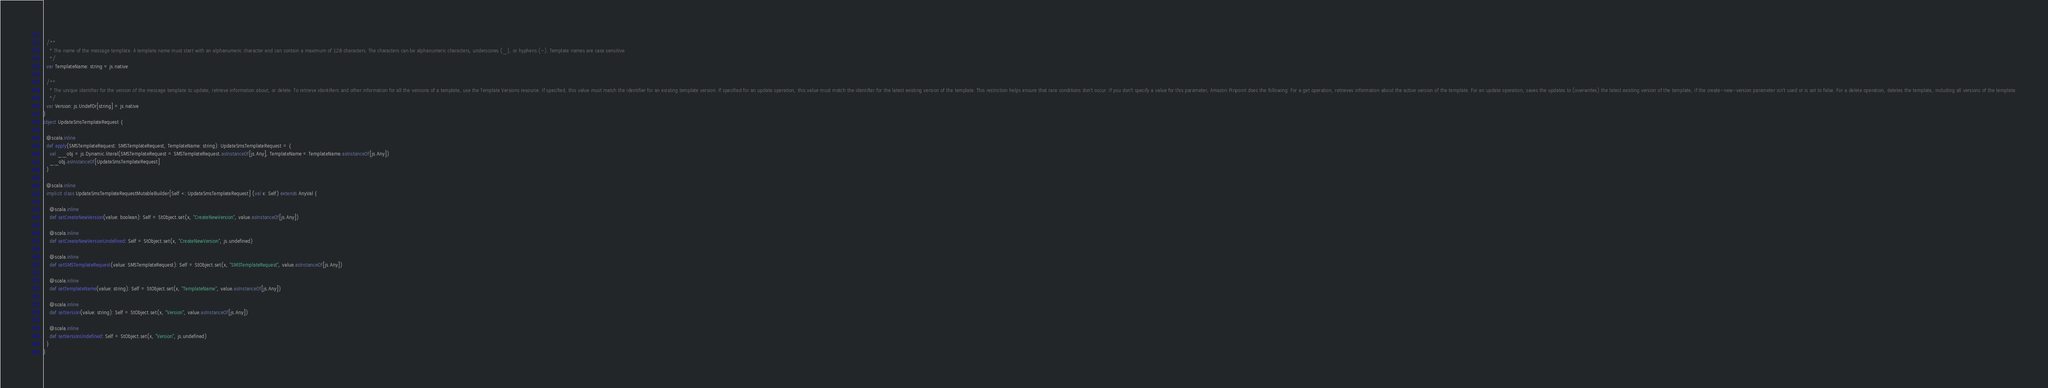<code> <loc_0><loc_0><loc_500><loc_500><_Scala_>  
  /**
    * The name of the message template. A template name must start with an alphanumeric character and can contain a maximum of 128 characters. The characters can be alphanumeric characters, underscores (_), or hyphens (-). Template names are case sensitive.
    */
  var TemplateName: string = js.native
  
  /**
    * The unique identifier for the version of the message template to update, retrieve information about, or delete. To retrieve identifiers and other information for all the versions of a template, use the Template Versions resource. If specified, this value must match the identifier for an existing template version. If specified for an update operation, this value must match the identifier for the latest existing version of the template. This restriction helps ensure that race conditions don't occur. If you don't specify a value for this parameter, Amazon Pinpoint does the following: For a get operation, retrieves information about the active version of the template. For an update operation, saves the updates to (overwrites) the latest existing version of the template, if the create-new-version parameter isn't used or is set to false. For a delete operation, deletes the template, including all versions of the template.
    */
  var Version: js.UndefOr[string] = js.native
}
object UpdateSmsTemplateRequest {
  
  @scala.inline
  def apply(SMSTemplateRequest: SMSTemplateRequest, TemplateName: string): UpdateSmsTemplateRequest = {
    val __obj = js.Dynamic.literal(SMSTemplateRequest = SMSTemplateRequest.asInstanceOf[js.Any], TemplateName = TemplateName.asInstanceOf[js.Any])
    __obj.asInstanceOf[UpdateSmsTemplateRequest]
  }
  
  @scala.inline
  implicit class UpdateSmsTemplateRequestMutableBuilder[Self <: UpdateSmsTemplateRequest] (val x: Self) extends AnyVal {
    
    @scala.inline
    def setCreateNewVersion(value: boolean): Self = StObject.set(x, "CreateNewVersion", value.asInstanceOf[js.Any])
    
    @scala.inline
    def setCreateNewVersionUndefined: Self = StObject.set(x, "CreateNewVersion", js.undefined)
    
    @scala.inline
    def setSMSTemplateRequest(value: SMSTemplateRequest): Self = StObject.set(x, "SMSTemplateRequest", value.asInstanceOf[js.Any])
    
    @scala.inline
    def setTemplateName(value: string): Self = StObject.set(x, "TemplateName", value.asInstanceOf[js.Any])
    
    @scala.inline
    def setVersion(value: string): Self = StObject.set(x, "Version", value.asInstanceOf[js.Any])
    
    @scala.inline
    def setVersionUndefined: Self = StObject.set(x, "Version", js.undefined)
  }
}
</code> 